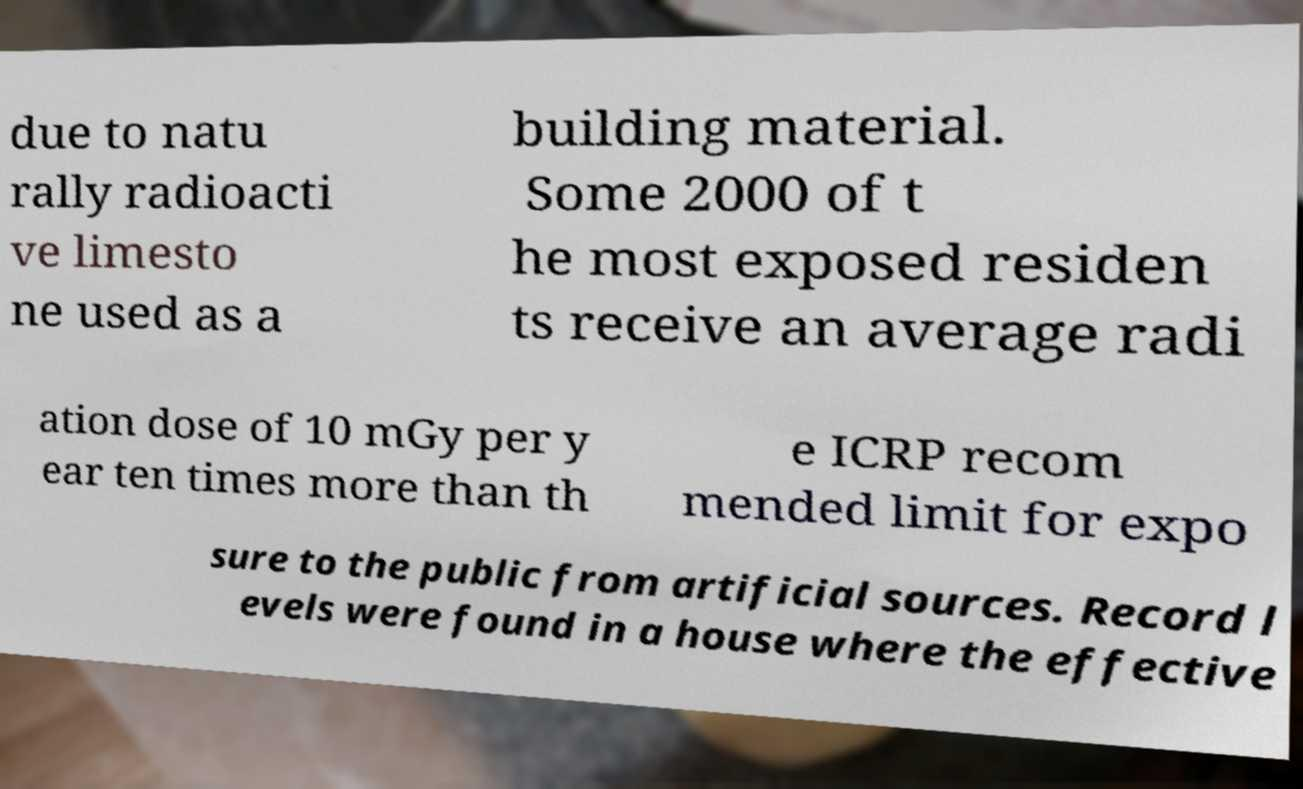Could you extract and type out the text from this image? due to natu rally radioacti ve limesto ne used as a building material. Some 2000 of t he most exposed residen ts receive an average radi ation dose of 10 mGy per y ear ten times more than th e ICRP recom mended limit for expo sure to the public from artificial sources. Record l evels were found in a house where the effective 